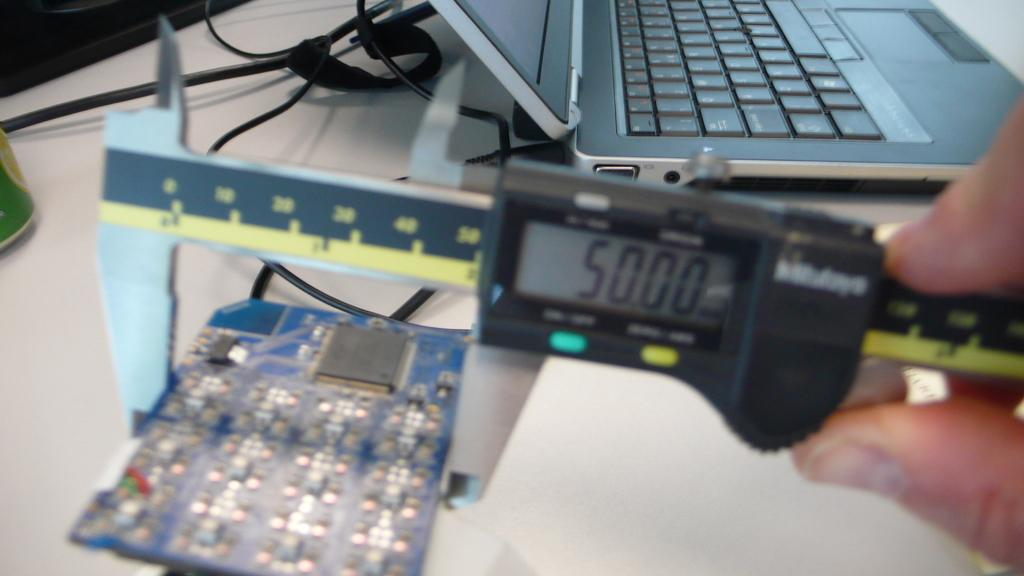<image>
Share a concise interpretation of the image provided. The readout on the electronic device says 5000. 